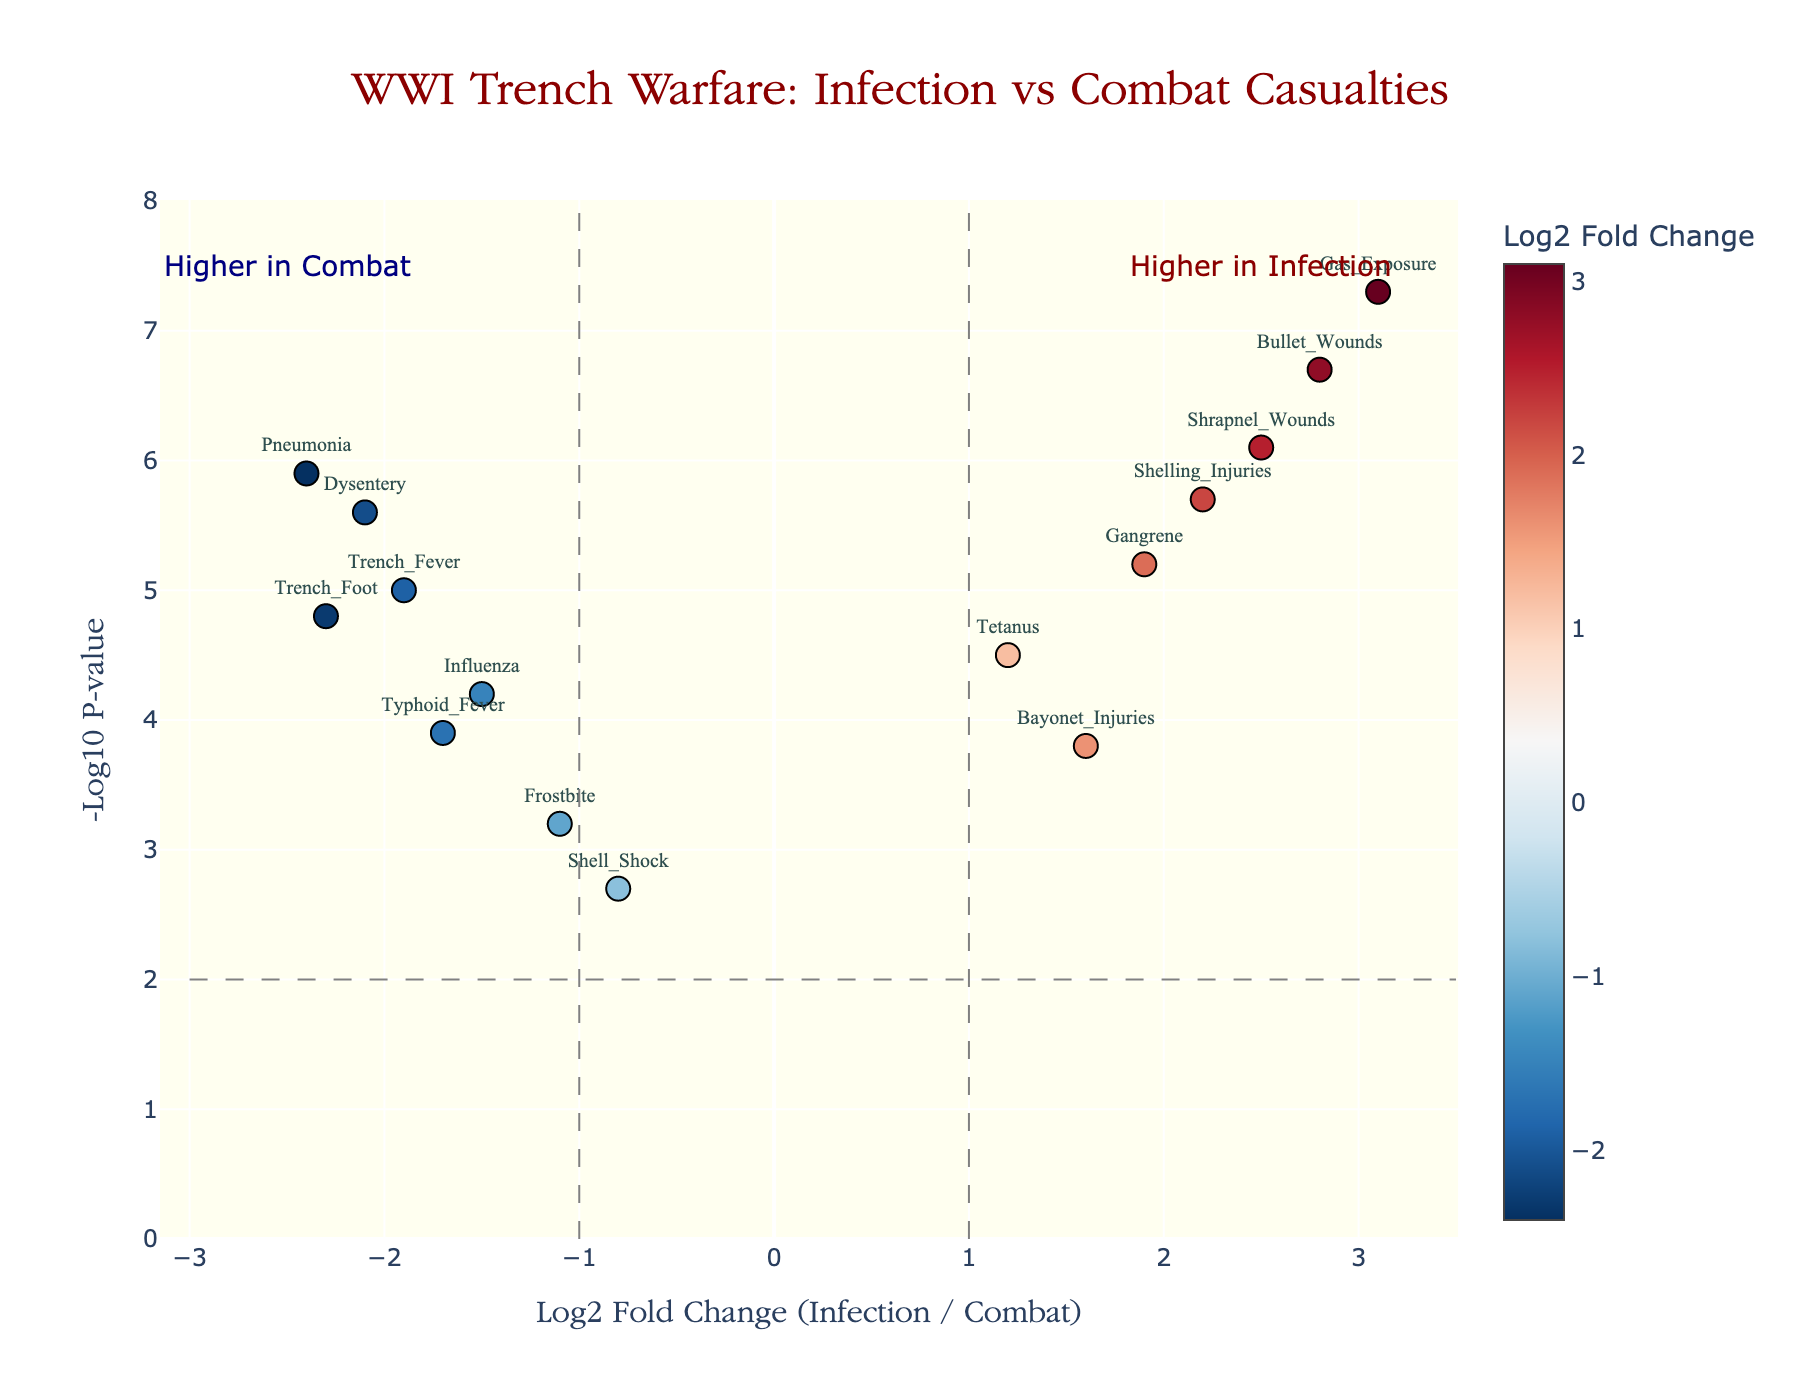What's the title of the plot? The title is at the top of the plot, and it reads "WWI Trench Warfare: Infection vs Combat Casualties."
Answer: "WWI Trench Warfare: Infection vs Combat Casualties" How many genes have a Log2 Fold Change greater than 2? Look at the x-axis (Log2 Fold Change) and count the points to the right of 2. There are 3 such genes: "Shrapnel_Wounds," "Gas_Exposure," and "Bullet_Wounds."
Answer: 3 Which data point has the highest -Log10 P-value? The highest point on the y-axis represents the highest -Log10 P-value. The highest point is 7.3 corresponding to "Gas_Exposure."
Answer: "Gas_Exposure" Identify the gene with Log2 Fold Change closest to zero and provide its value. Identify the point nearest to the center of the x-axis (Log2 Fold Change). "Shell_Shock" is closest to zero with a value of -0.8.
Answer: "Shell_Shock", -0.8 What distinguishes genes in the "Higher in Infection" region? Check what lies to the right of the vertical dashed line at Log2 Fold Change = 1. These include "Gangrene," "Shrapnel_Wounds," "Gas_Exposure," "Tetanus," "Bullet_Wounds," "Bayonet_Injuries," and "Shelling_Injuries."
Answer: They are above Log2 Fold Change = 1 Compare the Log2 Fold Changes of "Dysentery" and "Pneumonia" and determine which is more significant. Both are below 0, so find their locations on the x-axis. "Dysentery" has -2.1, and "Pneumonia" has -2.4.
Answer: "Pneumonia" (-2.4) Calculate the average -Log10 P-value for "Dysentery," "Trench_Fever," and "Pneumonia." Look up the y-values for these points: "Dysentery" (5.6), "Trench_Fever" (5.0), "Pneumonia" (5.9). Sum them (5.6 + 5.0 + 5.9 = 16.5) and divide by 3, giving 5.5.
Answer: 5.5 Which genes are less significant than a -Log10 p-value of 3 on the y-axis? Find points below y=3. These include "Shell_Shock" and "Frostbite."
Answer: "Shell_Shock," "Frostbite" Which gene has a positive Log2 Fold Change and a -Log10 P-value above 5? Locate points in both y > 5 and x > 0: "Gangrene," "Shrapnel_Wounds," "Gas_Exposure," "Bullet_Wounds," and "Shelling_Injuries."
Answer: "Gangrene," "Shrapnel_Wounds," "Gas_Exposure," "Bullet_Wounds," "Shelling_Injuries" 